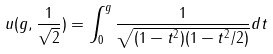<formula> <loc_0><loc_0><loc_500><loc_500>u ( g , \frac { 1 } { \sqrt { 2 } } ) = \int _ { 0 } ^ { g } \frac { 1 } { \sqrt { ( 1 - t ^ { 2 } ) ( 1 - t ^ { 2 } / 2 ) } } d t</formula> 